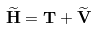<formula> <loc_0><loc_0><loc_500><loc_500>\widetilde { \mathbf H } = { \mathbf T } + \widetilde { \mathbf V }</formula> 